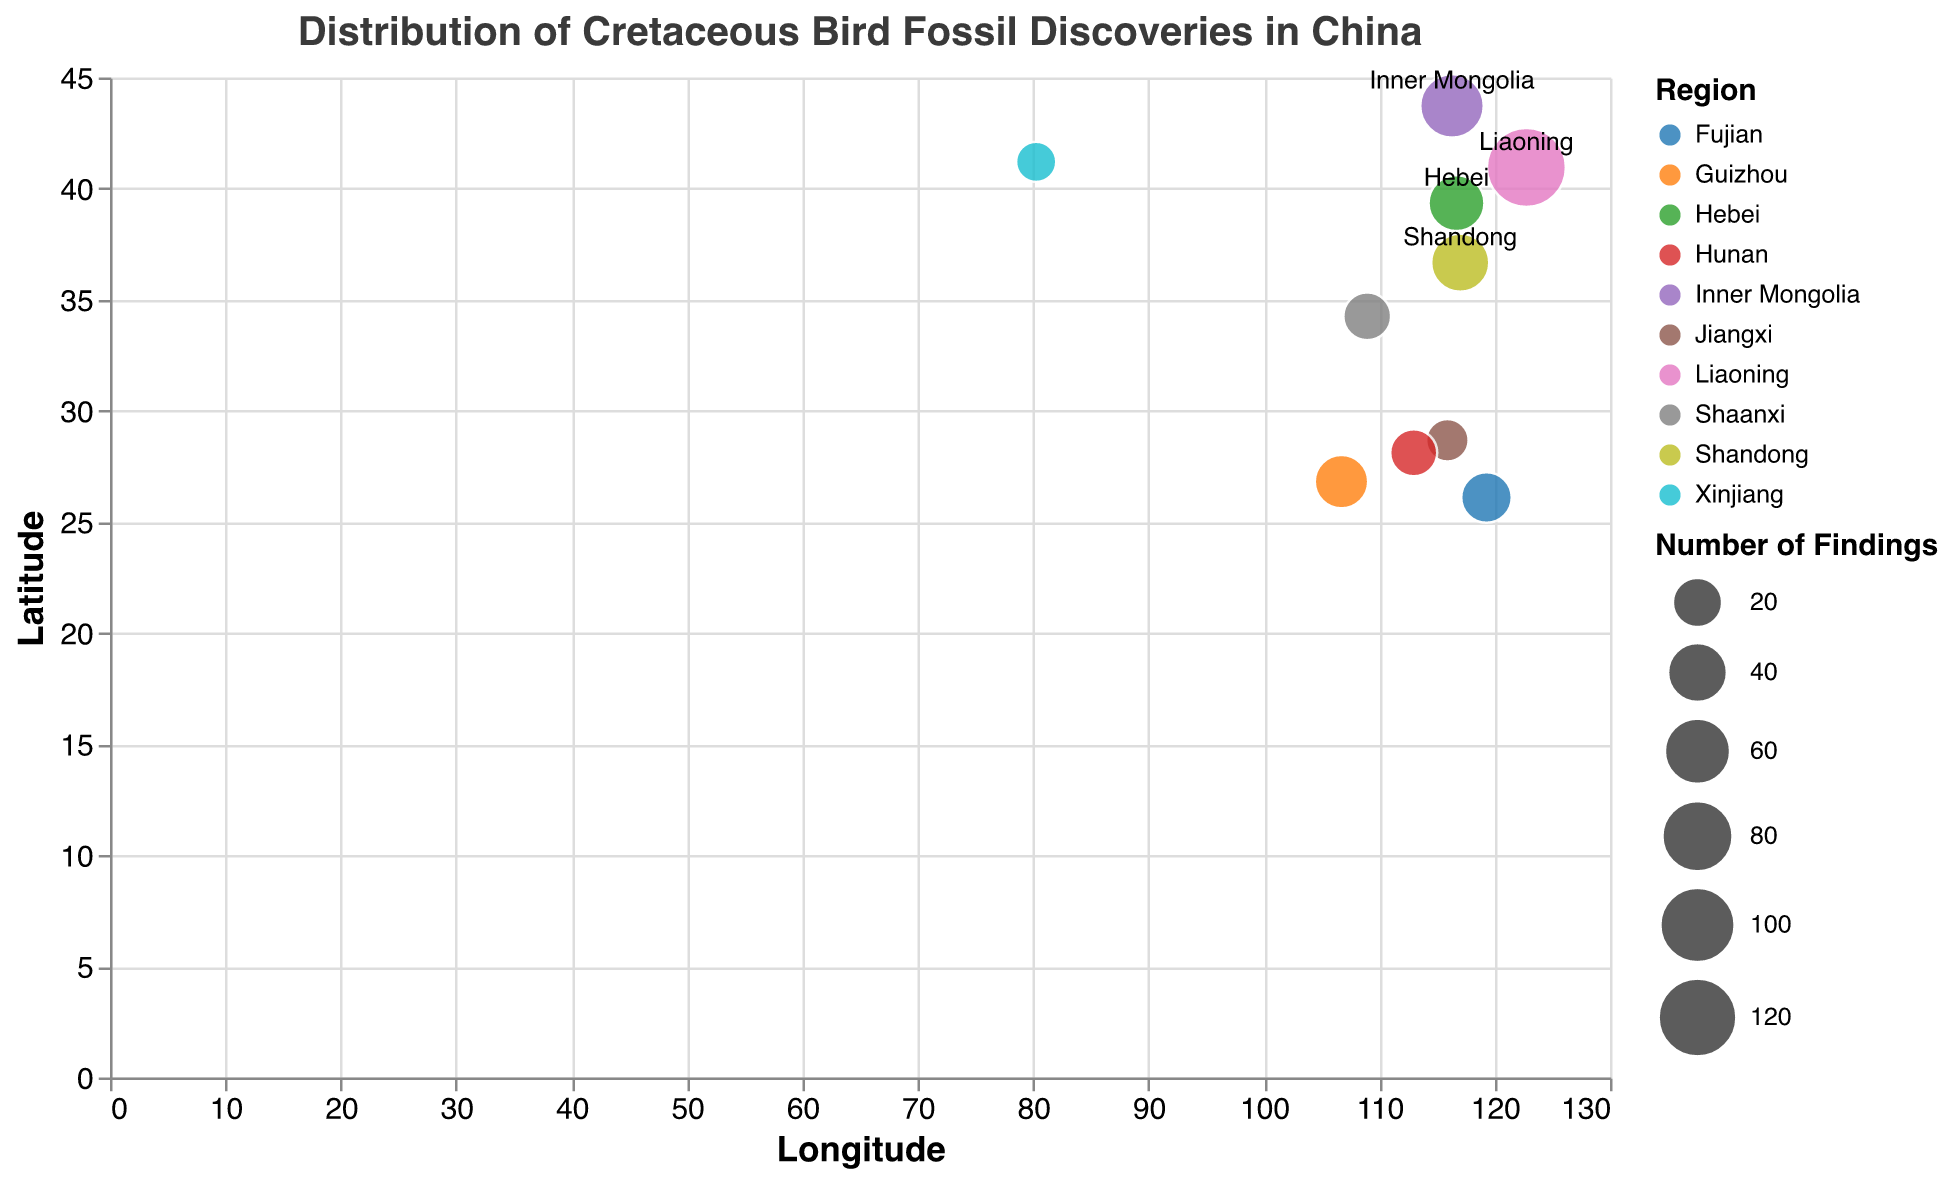What region has the highest number of fossil discoveries? The bubble chart shows each region marked by a circle, with the size of the circle representing the number of findings. The largest circle represents Liaoning with 120 findings.
Answer: Liaoning Which two regions have the closest number of fossil discoveries? Comparing the size of the bubbles, Fujian and Shandong have numbers close to each other, Fujian with 20 and Shandong with 35.
Answer: Fujian and Shandong How many regions have fewer than 20 fossil discoveries? Identify the bubbles representing fewer than 20 findings: Jiangxi (10), Hunan (15), and Xinjiang (8).
Answer: 3 regions What are the latitudes and longitudes for the region with the second-highest number of fossil discoveries? The second-largest circle is Inner Mongolia with 50 findings, located at a latitude of 43.722 and longitude of 116.307.
Answer: 43.722, 116.307 Which regions are located further west (higher longitude values) than Hebei? Check longitude values greater than Hebei's 116.696: Inner Mongolia (116.307), Shandong (117.020), and Liaoning (122.753).
Answer: Inner Mongolia, Shandong, Liaoning What is the sum of fossil findings in Jiangxi and Hunan? Jiangxi has 10 findings and Hunan has 15 findings, sum them: 10 + 15 = 25
Answer: 25 Which region has a higher number of findings, Guizhou or Hunan? Guizhou has 25 findings, whereas Hunan has 15, so Guizhou has more.
Answer: Guizhou Calculate the average number of findings for regions below 30 findings. Regions: Jiangxi (10), Hunan (15), Fujian (20), Xinjiang (8), Shaanxi (16), and Guizhou (25). Average = (10 + 15 + 20 + 8 + 16 + 25) / 6 = 15.67
Answer: 15.67 Which bubble represents Xinjiang, and what is its number of findings? The bubble positioned at latitude 41.204 and longitude 80.269 corresponds to Xinjiang with 8 findings.
Answer: 8 